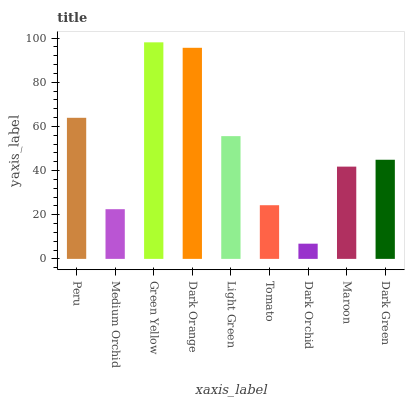Is Dark Orchid the minimum?
Answer yes or no. Yes. Is Green Yellow the maximum?
Answer yes or no. Yes. Is Medium Orchid the minimum?
Answer yes or no. No. Is Medium Orchid the maximum?
Answer yes or no. No. Is Peru greater than Medium Orchid?
Answer yes or no. Yes. Is Medium Orchid less than Peru?
Answer yes or no. Yes. Is Medium Orchid greater than Peru?
Answer yes or no. No. Is Peru less than Medium Orchid?
Answer yes or no. No. Is Dark Green the high median?
Answer yes or no. Yes. Is Dark Green the low median?
Answer yes or no. Yes. Is Peru the high median?
Answer yes or no. No. Is Light Green the low median?
Answer yes or no. No. 